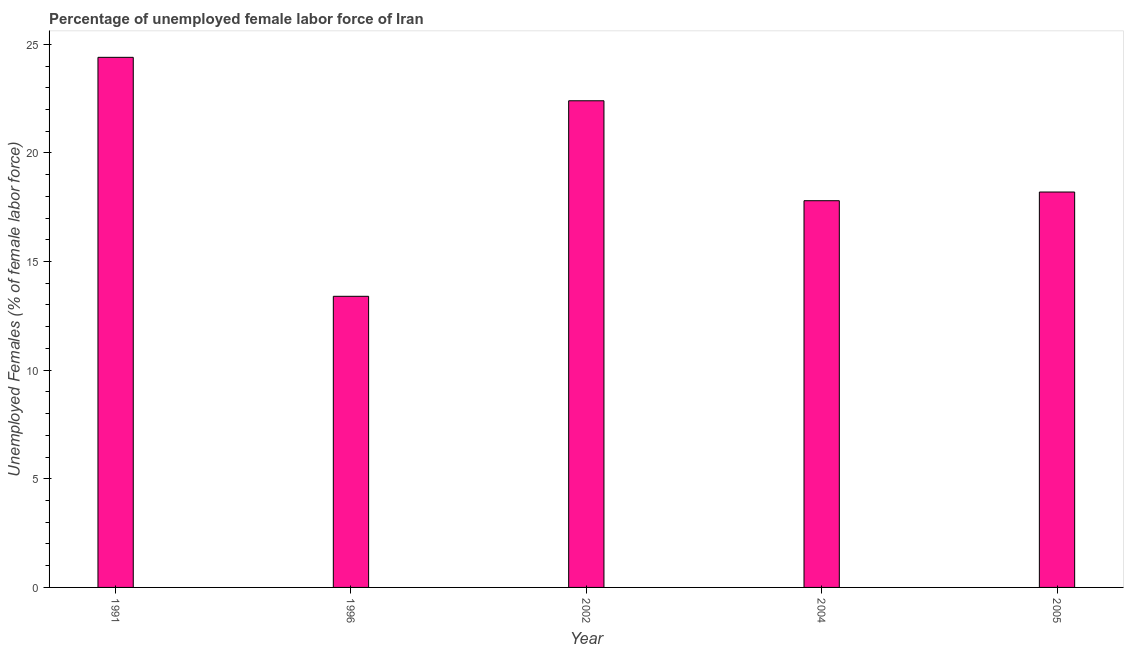What is the title of the graph?
Your answer should be very brief. Percentage of unemployed female labor force of Iran. What is the label or title of the X-axis?
Provide a short and direct response. Year. What is the label or title of the Y-axis?
Offer a very short reply. Unemployed Females (% of female labor force). What is the total unemployed female labour force in 2002?
Your answer should be very brief. 22.4. Across all years, what is the maximum total unemployed female labour force?
Keep it short and to the point. 24.4. Across all years, what is the minimum total unemployed female labour force?
Your response must be concise. 13.4. In which year was the total unemployed female labour force maximum?
Make the answer very short. 1991. What is the sum of the total unemployed female labour force?
Your answer should be very brief. 96.2. What is the average total unemployed female labour force per year?
Keep it short and to the point. 19.24. What is the median total unemployed female labour force?
Keep it short and to the point. 18.2. What is the ratio of the total unemployed female labour force in 2002 to that in 2005?
Your answer should be compact. 1.23. Is the total unemployed female labour force in 1996 less than that in 2004?
Provide a succinct answer. Yes. Is the difference between the total unemployed female labour force in 2002 and 2004 greater than the difference between any two years?
Offer a very short reply. No. How many bars are there?
Keep it short and to the point. 5. What is the difference between two consecutive major ticks on the Y-axis?
Your answer should be compact. 5. Are the values on the major ticks of Y-axis written in scientific E-notation?
Your response must be concise. No. What is the Unemployed Females (% of female labor force) in 1991?
Offer a terse response. 24.4. What is the Unemployed Females (% of female labor force) in 1996?
Your answer should be very brief. 13.4. What is the Unemployed Females (% of female labor force) in 2002?
Ensure brevity in your answer.  22.4. What is the Unemployed Females (% of female labor force) of 2004?
Give a very brief answer. 17.8. What is the Unemployed Females (% of female labor force) of 2005?
Offer a terse response. 18.2. What is the difference between the Unemployed Females (% of female labor force) in 1991 and 2002?
Your answer should be compact. 2. What is the difference between the Unemployed Females (% of female labor force) in 1991 and 2005?
Make the answer very short. 6.2. What is the difference between the Unemployed Females (% of female labor force) in 1996 and 2004?
Keep it short and to the point. -4.4. What is the difference between the Unemployed Females (% of female labor force) in 1996 and 2005?
Your response must be concise. -4.8. What is the difference between the Unemployed Females (% of female labor force) in 2002 and 2004?
Your response must be concise. 4.6. What is the ratio of the Unemployed Females (% of female labor force) in 1991 to that in 1996?
Your answer should be compact. 1.82. What is the ratio of the Unemployed Females (% of female labor force) in 1991 to that in 2002?
Give a very brief answer. 1.09. What is the ratio of the Unemployed Females (% of female labor force) in 1991 to that in 2004?
Your response must be concise. 1.37. What is the ratio of the Unemployed Females (% of female labor force) in 1991 to that in 2005?
Provide a succinct answer. 1.34. What is the ratio of the Unemployed Females (% of female labor force) in 1996 to that in 2002?
Give a very brief answer. 0.6. What is the ratio of the Unemployed Females (% of female labor force) in 1996 to that in 2004?
Keep it short and to the point. 0.75. What is the ratio of the Unemployed Females (% of female labor force) in 1996 to that in 2005?
Your answer should be very brief. 0.74. What is the ratio of the Unemployed Females (% of female labor force) in 2002 to that in 2004?
Offer a terse response. 1.26. What is the ratio of the Unemployed Females (% of female labor force) in 2002 to that in 2005?
Provide a short and direct response. 1.23. 